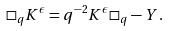<formula> <loc_0><loc_0><loc_500><loc_500>\Box _ { q } K ^ { \epsilon } = q ^ { - 2 } K ^ { \epsilon } \Box _ { q } - Y \, .</formula> 